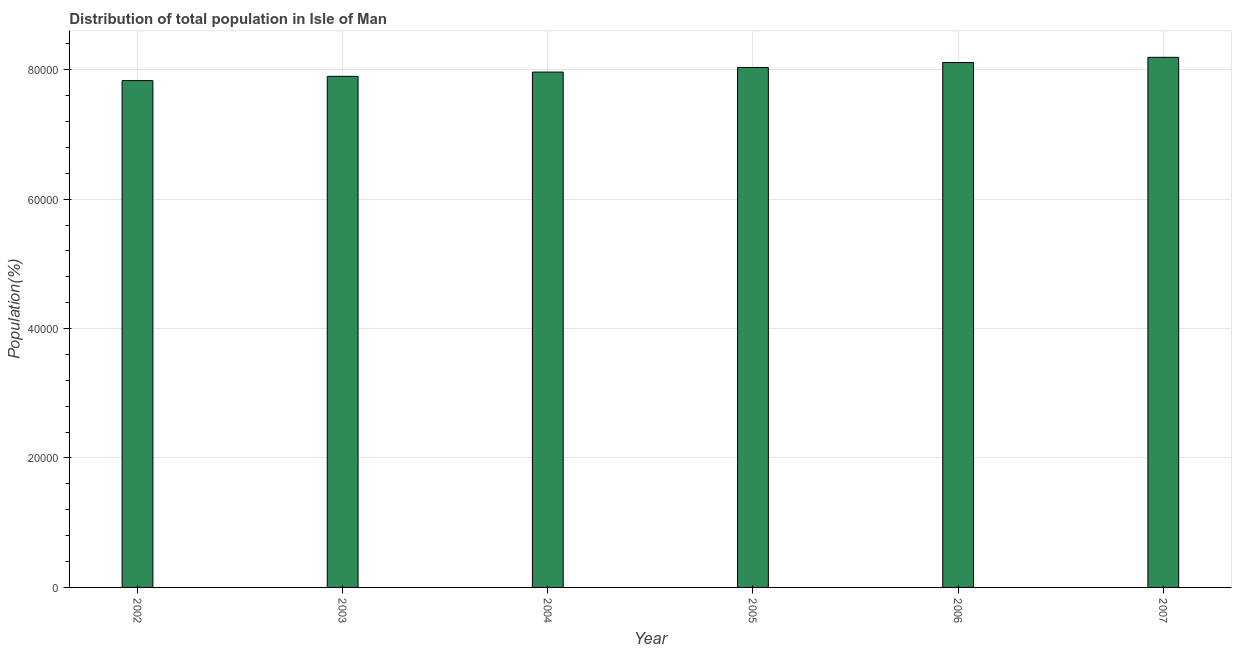Does the graph contain any zero values?
Offer a very short reply. No. Does the graph contain grids?
Provide a succinct answer. Yes. What is the title of the graph?
Offer a very short reply. Distribution of total population in Isle of Man . What is the label or title of the Y-axis?
Your answer should be compact. Population(%). What is the population in 2004?
Your answer should be very brief. 7.96e+04. Across all years, what is the maximum population?
Provide a short and direct response. 8.19e+04. Across all years, what is the minimum population?
Offer a terse response. 7.83e+04. What is the sum of the population?
Offer a terse response. 4.80e+05. What is the difference between the population in 2002 and 2006?
Your answer should be compact. -2792. What is the average population per year?
Your answer should be very brief. 8.00e+04. What is the median population?
Your answer should be compact. 8.00e+04. In how many years, is the population greater than 60000 %?
Provide a short and direct response. 6. Do a majority of the years between 2004 and 2005 (inclusive) have population greater than 76000 %?
Provide a short and direct response. Yes. Is the population in 2002 less than that in 2007?
Offer a terse response. Yes. What is the difference between the highest and the second highest population?
Your response must be concise. 804. Is the sum of the population in 2004 and 2007 greater than the maximum population across all years?
Offer a terse response. Yes. What is the difference between the highest and the lowest population?
Keep it short and to the point. 3596. How many bars are there?
Your answer should be very brief. 6. Are the values on the major ticks of Y-axis written in scientific E-notation?
Your answer should be very brief. No. What is the Population(%) of 2002?
Ensure brevity in your answer.  7.83e+04. What is the Population(%) of 2003?
Provide a succinct answer. 7.90e+04. What is the Population(%) of 2004?
Make the answer very short. 7.96e+04. What is the Population(%) in 2005?
Make the answer very short. 8.03e+04. What is the Population(%) of 2006?
Make the answer very short. 8.11e+04. What is the Population(%) in 2007?
Provide a succinct answer. 8.19e+04. What is the difference between the Population(%) in 2002 and 2003?
Your answer should be very brief. -657. What is the difference between the Population(%) in 2002 and 2004?
Make the answer very short. -1318. What is the difference between the Population(%) in 2002 and 2005?
Ensure brevity in your answer.  -2027. What is the difference between the Population(%) in 2002 and 2006?
Your answer should be very brief. -2792. What is the difference between the Population(%) in 2002 and 2007?
Your answer should be very brief. -3596. What is the difference between the Population(%) in 2003 and 2004?
Offer a terse response. -661. What is the difference between the Population(%) in 2003 and 2005?
Offer a terse response. -1370. What is the difference between the Population(%) in 2003 and 2006?
Provide a short and direct response. -2135. What is the difference between the Population(%) in 2003 and 2007?
Keep it short and to the point. -2939. What is the difference between the Population(%) in 2004 and 2005?
Make the answer very short. -709. What is the difference between the Population(%) in 2004 and 2006?
Offer a terse response. -1474. What is the difference between the Population(%) in 2004 and 2007?
Provide a succinct answer. -2278. What is the difference between the Population(%) in 2005 and 2006?
Your answer should be very brief. -765. What is the difference between the Population(%) in 2005 and 2007?
Your answer should be very brief. -1569. What is the difference between the Population(%) in 2006 and 2007?
Your answer should be very brief. -804. What is the ratio of the Population(%) in 2002 to that in 2003?
Give a very brief answer. 0.99. What is the ratio of the Population(%) in 2002 to that in 2004?
Offer a very short reply. 0.98. What is the ratio of the Population(%) in 2002 to that in 2006?
Keep it short and to the point. 0.97. What is the ratio of the Population(%) in 2002 to that in 2007?
Your response must be concise. 0.96. What is the ratio of the Population(%) in 2003 to that in 2005?
Your answer should be compact. 0.98. What is the ratio of the Population(%) in 2003 to that in 2006?
Provide a short and direct response. 0.97. What is the ratio of the Population(%) in 2003 to that in 2007?
Provide a succinct answer. 0.96. What is the ratio of the Population(%) in 2004 to that in 2006?
Provide a short and direct response. 0.98. What is the ratio of the Population(%) in 2005 to that in 2006?
Your answer should be very brief. 0.99. 